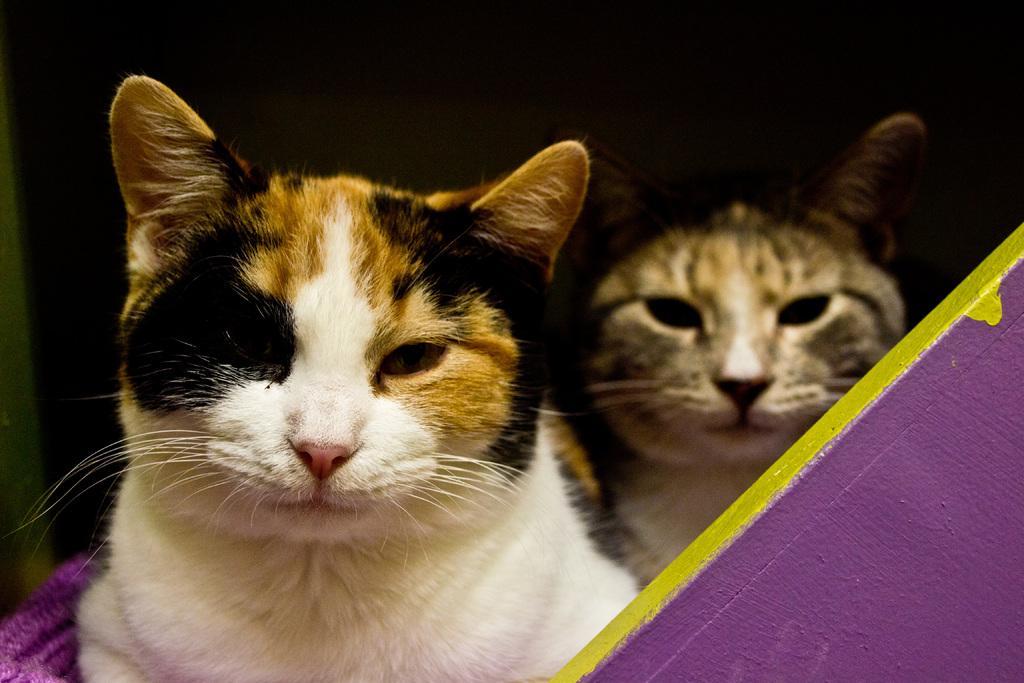How would you summarize this image in a sentence or two? In this image we can see there are cats and there is the wall. At the left side the object looks like a cloth and there is the dark background. 